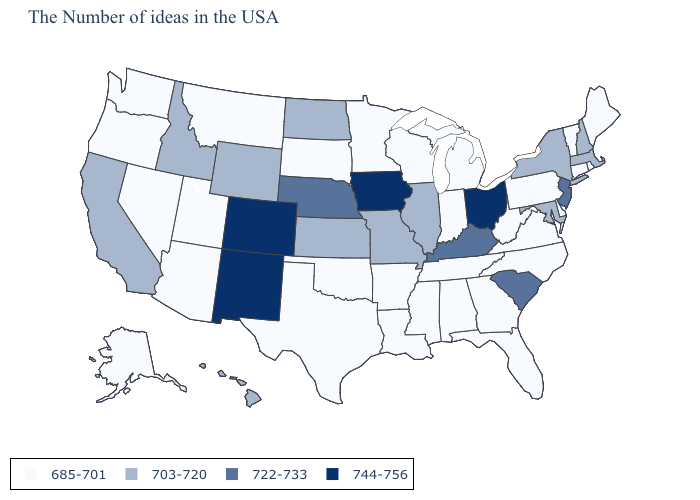Which states hav the highest value in the Northeast?
Quick response, please. New Jersey. What is the highest value in states that border Rhode Island?
Give a very brief answer. 703-720. Name the states that have a value in the range 685-701?
Quick response, please. Maine, Rhode Island, Vermont, Connecticut, Delaware, Pennsylvania, Virginia, North Carolina, West Virginia, Florida, Georgia, Michigan, Indiana, Alabama, Tennessee, Wisconsin, Mississippi, Louisiana, Arkansas, Minnesota, Oklahoma, Texas, South Dakota, Utah, Montana, Arizona, Nevada, Washington, Oregon, Alaska. Which states have the lowest value in the West?
Quick response, please. Utah, Montana, Arizona, Nevada, Washington, Oregon, Alaska. Name the states that have a value in the range 722-733?
Be succinct. New Jersey, South Carolina, Kentucky, Nebraska. What is the value of West Virginia?
Concise answer only. 685-701. Is the legend a continuous bar?
Answer briefly. No. What is the lowest value in the USA?
Be succinct. 685-701. Name the states that have a value in the range 744-756?
Quick response, please. Ohio, Iowa, Colorado, New Mexico. Name the states that have a value in the range 703-720?
Give a very brief answer. Massachusetts, New Hampshire, New York, Maryland, Illinois, Missouri, Kansas, North Dakota, Wyoming, Idaho, California, Hawaii. Which states have the lowest value in the USA?
Short answer required. Maine, Rhode Island, Vermont, Connecticut, Delaware, Pennsylvania, Virginia, North Carolina, West Virginia, Florida, Georgia, Michigan, Indiana, Alabama, Tennessee, Wisconsin, Mississippi, Louisiana, Arkansas, Minnesota, Oklahoma, Texas, South Dakota, Utah, Montana, Arizona, Nevada, Washington, Oregon, Alaska. Name the states that have a value in the range 744-756?
Give a very brief answer. Ohio, Iowa, Colorado, New Mexico. What is the value of Delaware?
Answer briefly. 685-701. What is the highest value in states that border New York?
Quick response, please. 722-733. 